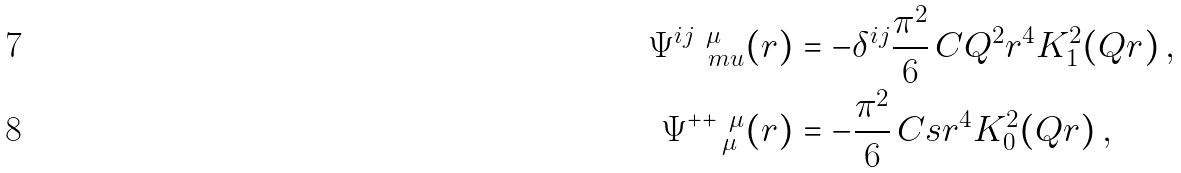<formula> <loc_0><loc_0><loc_500><loc_500>\Psi _ { \quad m u } ^ { i j \ \mu } ( r ) & = - \delta ^ { i j } \frac { \pi ^ { 2 } } { 6 } \, C Q ^ { 2 } r ^ { 4 } K _ { 1 } ^ { 2 } ( Q r ) \, , \\ \Psi _ { \quad \mu } ^ { + + \ \mu } ( r ) & = - \frac { \pi ^ { 2 } } { 6 } \, C s r ^ { 4 } K _ { 0 } ^ { 2 } ( Q r ) \, ,</formula> 